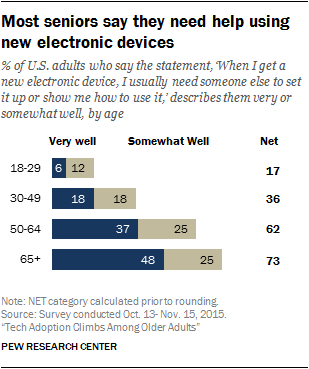Mention a couple of crucial points in this snapshot. The net value of the first bar is 17 dollars. The total value of the largest net and the smallest net is 90. 